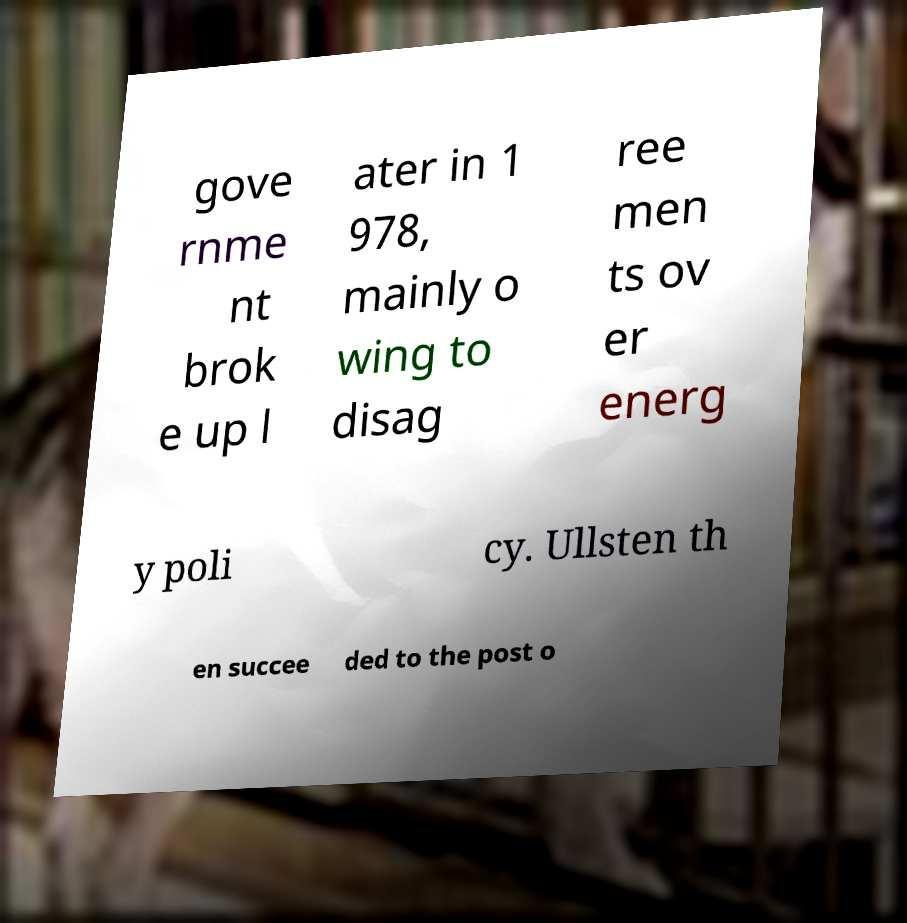Can you read and provide the text displayed in the image?This photo seems to have some interesting text. Can you extract and type it out for me? gove rnme nt brok e up l ater in 1 978, mainly o wing to disag ree men ts ov er energ y poli cy. Ullsten th en succee ded to the post o 